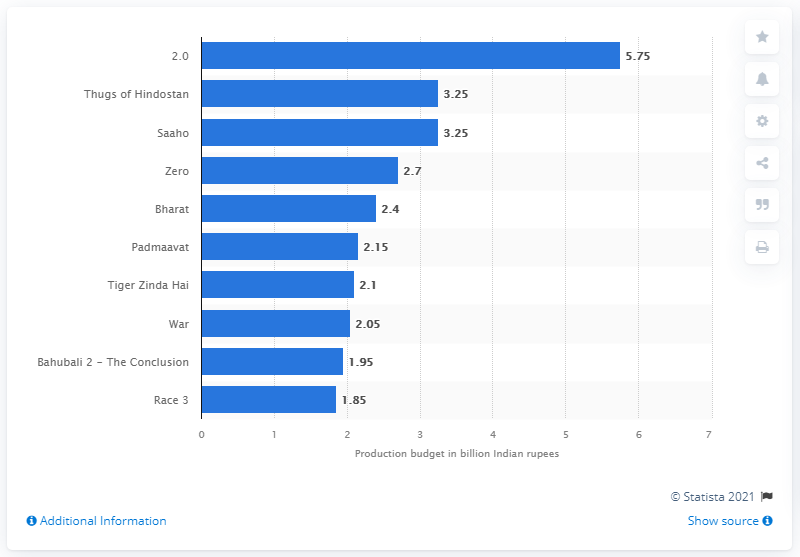Identify some key points in this picture. The second movie with the highest budget in 2019 was Saaho. 